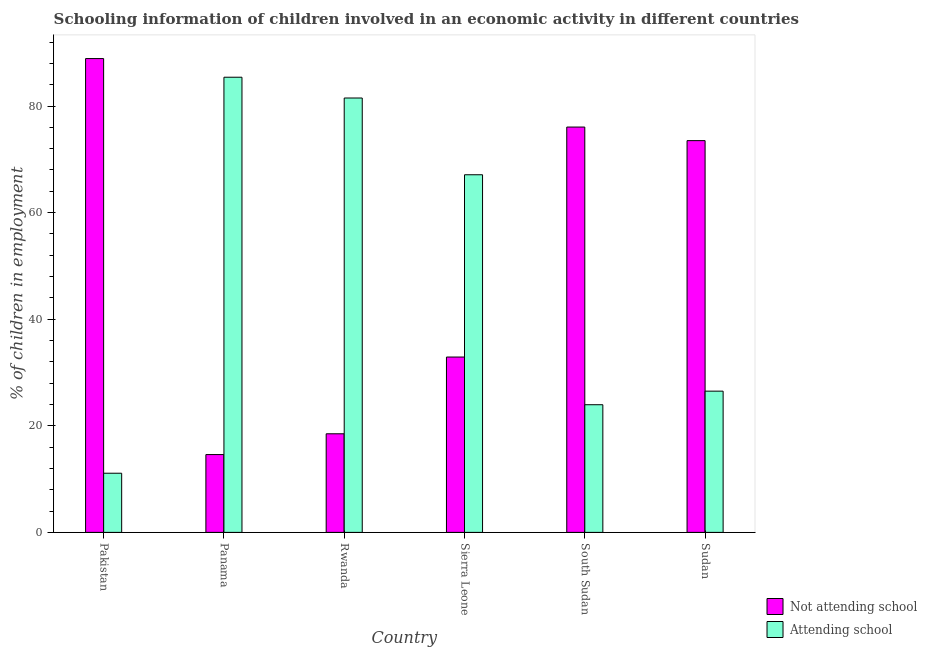Are the number of bars on each tick of the X-axis equal?
Give a very brief answer. Yes. How many bars are there on the 6th tick from the left?
Give a very brief answer. 2. How many bars are there on the 6th tick from the right?
Your response must be concise. 2. What is the label of the 5th group of bars from the left?
Provide a short and direct response. South Sudan. What is the percentage of employed children who are not attending school in South Sudan?
Ensure brevity in your answer.  76.05. Across all countries, what is the maximum percentage of employed children who are attending school?
Provide a short and direct response. 85.4. Across all countries, what is the minimum percentage of employed children who are not attending school?
Your response must be concise. 14.6. What is the total percentage of employed children who are not attending school in the graph?
Offer a terse response. 304.45. What is the difference between the percentage of employed children who are attending school in South Sudan and that in Sudan?
Provide a short and direct response. -2.55. What is the difference between the percentage of employed children who are not attending school in Sierra Leone and the percentage of employed children who are attending school in South Sudan?
Ensure brevity in your answer.  8.95. What is the average percentage of employed children who are not attending school per country?
Ensure brevity in your answer.  50.74. What is the difference between the percentage of employed children who are attending school and percentage of employed children who are not attending school in Pakistan?
Your response must be concise. -77.8. What is the ratio of the percentage of employed children who are not attending school in South Sudan to that in Sudan?
Your answer should be very brief. 1.03. Is the difference between the percentage of employed children who are attending school in Rwanda and Sudan greater than the difference between the percentage of employed children who are not attending school in Rwanda and Sudan?
Make the answer very short. Yes. What is the difference between the highest and the second highest percentage of employed children who are attending school?
Make the answer very short. 3.9. What is the difference between the highest and the lowest percentage of employed children who are not attending school?
Your answer should be compact. 74.3. In how many countries, is the percentage of employed children who are not attending school greater than the average percentage of employed children who are not attending school taken over all countries?
Keep it short and to the point. 3. Is the sum of the percentage of employed children who are not attending school in Pakistan and Panama greater than the maximum percentage of employed children who are attending school across all countries?
Your response must be concise. Yes. What does the 2nd bar from the left in Rwanda represents?
Your answer should be compact. Attending school. What does the 1st bar from the right in Sudan represents?
Your response must be concise. Attending school. How many bars are there?
Offer a terse response. 12. What is the difference between two consecutive major ticks on the Y-axis?
Provide a succinct answer. 20. Are the values on the major ticks of Y-axis written in scientific E-notation?
Your answer should be very brief. No. How many legend labels are there?
Provide a short and direct response. 2. How are the legend labels stacked?
Keep it short and to the point. Vertical. What is the title of the graph?
Your response must be concise. Schooling information of children involved in an economic activity in different countries. What is the label or title of the Y-axis?
Keep it short and to the point. % of children in employment. What is the % of children in employment in Not attending school in Pakistan?
Provide a succinct answer. 88.9. What is the % of children in employment in Attending school in Pakistan?
Your answer should be very brief. 11.1. What is the % of children in employment in Not attending school in Panama?
Offer a very short reply. 14.6. What is the % of children in employment in Attending school in Panama?
Ensure brevity in your answer.  85.4. What is the % of children in employment of Not attending school in Rwanda?
Provide a succinct answer. 18.5. What is the % of children in employment in Attending school in Rwanda?
Provide a short and direct response. 81.5. What is the % of children in employment of Not attending school in Sierra Leone?
Your answer should be compact. 32.9. What is the % of children in employment of Attending school in Sierra Leone?
Offer a terse response. 67.1. What is the % of children in employment in Not attending school in South Sudan?
Your response must be concise. 76.05. What is the % of children in employment in Attending school in South Sudan?
Ensure brevity in your answer.  23.95. What is the % of children in employment in Not attending school in Sudan?
Your response must be concise. 73.5. What is the % of children in employment of Attending school in Sudan?
Make the answer very short. 26.5. Across all countries, what is the maximum % of children in employment in Not attending school?
Provide a short and direct response. 88.9. Across all countries, what is the maximum % of children in employment in Attending school?
Your answer should be very brief. 85.4. What is the total % of children in employment of Not attending school in the graph?
Give a very brief answer. 304.45. What is the total % of children in employment of Attending school in the graph?
Give a very brief answer. 295.55. What is the difference between the % of children in employment in Not attending school in Pakistan and that in Panama?
Your answer should be compact. 74.3. What is the difference between the % of children in employment of Attending school in Pakistan and that in Panama?
Offer a terse response. -74.3. What is the difference between the % of children in employment in Not attending school in Pakistan and that in Rwanda?
Provide a short and direct response. 70.4. What is the difference between the % of children in employment of Attending school in Pakistan and that in Rwanda?
Offer a very short reply. -70.4. What is the difference between the % of children in employment in Attending school in Pakistan and that in Sierra Leone?
Provide a short and direct response. -56. What is the difference between the % of children in employment of Not attending school in Pakistan and that in South Sudan?
Your answer should be compact. 12.85. What is the difference between the % of children in employment in Attending school in Pakistan and that in South Sudan?
Your response must be concise. -12.85. What is the difference between the % of children in employment of Not attending school in Pakistan and that in Sudan?
Make the answer very short. 15.4. What is the difference between the % of children in employment in Attending school in Pakistan and that in Sudan?
Your answer should be compact. -15.4. What is the difference between the % of children in employment of Not attending school in Panama and that in Rwanda?
Keep it short and to the point. -3.9. What is the difference between the % of children in employment of Not attending school in Panama and that in Sierra Leone?
Offer a terse response. -18.3. What is the difference between the % of children in employment in Not attending school in Panama and that in South Sudan?
Provide a short and direct response. -61.45. What is the difference between the % of children in employment of Attending school in Panama and that in South Sudan?
Give a very brief answer. 61.45. What is the difference between the % of children in employment in Not attending school in Panama and that in Sudan?
Your answer should be very brief. -58.9. What is the difference between the % of children in employment of Attending school in Panama and that in Sudan?
Give a very brief answer. 58.9. What is the difference between the % of children in employment of Not attending school in Rwanda and that in Sierra Leone?
Offer a very short reply. -14.4. What is the difference between the % of children in employment of Attending school in Rwanda and that in Sierra Leone?
Offer a very short reply. 14.4. What is the difference between the % of children in employment of Not attending school in Rwanda and that in South Sudan?
Offer a very short reply. -57.55. What is the difference between the % of children in employment of Attending school in Rwanda and that in South Sudan?
Your answer should be very brief. 57.55. What is the difference between the % of children in employment in Not attending school in Rwanda and that in Sudan?
Your response must be concise. -55. What is the difference between the % of children in employment of Attending school in Rwanda and that in Sudan?
Give a very brief answer. 55. What is the difference between the % of children in employment in Not attending school in Sierra Leone and that in South Sudan?
Your answer should be very brief. -43.15. What is the difference between the % of children in employment of Attending school in Sierra Leone and that in South Sudan?
Make the answer very short. 43.15. What is the difference between the % of children in employment in Not attending school in Sierra Leone and that in Sudan?
Offer a terse response. -40.6. What is the difference between the % of children in employment in Attending school in Sierra Leone and that in Sudan?
Your response must be concise. 40.6. What is the difference between the % of children in employment of Not attending school in South Sudan and that in Sudan?
Your response must be concise. 2.55. What is the difference between the % of children in employment of Attending school in South Sudan and that in Sudan?
Give a very brief answer. -2.55. What is the difference between the % of children in employment in Not attending school in Pakistan and the % of children in employment in Attending school in Rwanda?
Your answer should be compact. 7.4. What is the difference between the % of children in employment in Not attending school in Pakistan and the % of children in employment in Attending school in Sierra Leone?
Provide a succinct answer. 21.8. What is the difference between the % of children in employment in Not attending school in Pakistan and the % of children in employment in Attending school in South Sudan?
Offer a terse response. 64.95. What is the difference between the % of children in employment in Not attending school in Pakistan and the % of children in employment in Attending school in Sudan?
Offer a very short reply. 62.4. What is the difference between the % of children in employment in Not attending school in Panama and the % of children in employment in Attending school in Rwanda?
Give a very brief answer. -66.9. What is the difference between the % of children in employment in Not attending school in Panama and the % of children in employment in Attending school in Sierra Leone?
Make the answer very short. -52.5. What is the difference between the % of children in employment in Not attending school in Panama and the % of children in employment in Attending school in South Sudan?
Give a very brief answer. -9.35. What is the difference between the % of children in employment of Not attending school in Panama and the % of children in employment of Attending school in Sudan?
Keep it short and to the point. -11.9. What is the difference between the % of children in employment of Not attending school in Rwanda and the % of children in employment of Attending school in Sierra Leone?
Your answer should be very brief. -48.6. What is the difference between the % of children in employment of Not attending school in Rwanda and the % of children in employment of Attending school in South Sudan?
Provide a short and direct response. -5.45. What is the difference between the % of children in employment in Not attending school in Rwanda and the % of children in employment in Attending school in Sudan?
Your answer should be compact. -8. What is the difference between the % of children in employment of Not attending school in Sierra Leone and the % of children in employment of Attending school in South Sudan?
Offer a very short reply. 8.95. What is the difference between the % of children in employment of Not attending school in Sierra Leone and the % of children in employment of Attending school in Sudan?
Keep it short and to the point. 6.4. What is the difference between the % of children in employment of Not attending school in South Sudan and the % of children in employment of Attending school in Sudan?
Offer a terse response. 49.55. What is the average % of children in employment in Not attending school per country?
Provide a succinct answer. 50.74. What is the average % of children in employment in Attending school per country?
Keep it short and to the point. 49.26. What is the difference between the % of children in employment in Not attending school and % of children in employment in Attending school in Pakistan?
Make the answer very short. 77.8. What is the difference between the % of children in employment in Not attending school and % of children in employment in Attending school in Panama?
Ensure brevity in your answer.  -70.8. What is the difference between the % of children in employment of Not attending school and % of children in employment of Attending school in Rwanda?
Your answer should be very brief. -63. What is the difference between the % of children in employment in Not attending school and % of children in employment in Attending school in Sierra Leone?
Ensure brevity in your answer.  -34.2. What is the difference between the % of children in employment of Not attending school and % of children in employment of Attending school in South Sudan?
Provide a succinct answer. 52.1. What is the difference between the % of children in employment in Not attending school and % of children in employment in Attending school in Sudan?
Offer a terse response. 47. What is the ratio of the % of children in employment of Not attending school in Pakistan to that in Panama?
Your response must be concise. 6.09. What is the ratio of the % of children in employment of Attending school in Pakistan to that in Panama?
Provide a succinct answer. 0.13. What is the ratio of the % of children in employment of Not attending school in Pakistan to that in Rwanda?
Offer a terse response. 4.81. What is the ratio of the % of children in employment of Attending school in Pakistan to that in Rwanda?
Your answer should be very brief. 0.14. What is the ratio of the % of children in employment in Not attending school in Pakistan to that in Sierra Leone?
Give a very brief answer. 2.7. What is the ratio of the % of children in employment in Attending school in Pakistan to that in Sierra Leone?
Give a very brief answer. 0.17. What is the ratio of the % of children in employment in Not attending school in Pakistan to that in South Sudan?
Give a very brief answer. 1.17. What is the ratio of the % of children in employment in Attending school in Pakistan to that in South Sudan?
Make the answer very short. 0.46. What is the ratio of the % of children in employment in Not attending school in Pakistan to that in Sudan?
Offer a terse response. 1.21. What is the ratio of the % of children in employment in Attending school in Pakistan to that in Sudan?
Ensure brevity in your answer.  0.42. What is the ratio of the % of children in employment of Not attending school in Panama to that in Rwanda?
Provide a short and direct response. 0.79. What is the ratio of the % of children in employment of Attending school in Panama to that in Rwanda?
Give a very brief answer. 1.05. What is the ratio of the % of children in employment in Not attending school in Panama to that in Sierra Leone?
Ensure brevity in your answer.  0.44. What is the ratio of the % of children in employment of Attending school in Panama to that in Sierra Leone?
Provide a short and direct response. 1.27. What is the ratio of the % of children in employment in Not attending school in Panama to that in South Sudan?
Offer a very short reply. 0.19. What is the ratio of the % of children in employment in Attending school in Panama to that in South Sudan?
Offer a very short reply. 3.57. What is the ratio of the % of children in employment of Not attending school in Panama to that in Sudan?
Offer a very short reply. 0.2. What is the ratio of the % of children in employment of Attending school in Panama to that in Sudan?
Provide a short and direct response. 3.22. What is the ratio of the % of children in employment of Not attending school in Rwanda to that in Sierra Leone?
Your answer should be compact. 0.56. What is the ratio of the % of children in employment of Attending school in Rwanda to that in Sierra Leone?
Ensure brevity in your answer.  1.21. What is the ratio of the % of children in employment in Not attending school in Rwanda to that in South Sudan?
Give a very brief answer. 0.24. What is the ratio of the % of children in employment in Attending school in Rwanda to that in South Sudan?
Make the answer very short. 3.4. What is the ratio of the % of children in employment in Not attending school in Rwanda to that in Sudan?
Provide a short and direct response. 0.25. What is the ratio of the % of children in employment in Attending school in Rwanda to that in Sudan?
Ensure brevity in your answer.  3.08. What is the ratio of the % of children in employment of Not attending school in Sierra Leone to that in South Sudan?
Offer a very short reply. 0.43. What is the ratio of the % of children in employment in Attending school in Sierra Leone to that in South Sudan?
Give a very brief answer. 2.8. What is the ratio of the % of children in employment in Not attending school in Sierra Leone to that in Sudan?
Offer a terse response. 0.45. What is the ratio of the % of children in employment of Attending school in Sierra Leone to that in Sudan?
Give a very brief answer. 2.53. What is the ratio of the % of children in employment of Not attending school in South Sudan to that in Sudan?
Provide a short and direct response. 1.03. What is the ratio of the % of children in employment in Attending school in South Sudan to that in Sudan?
Ensure brevity in your answer.  0.9. What is the difference between the highest and the second highest % of children in employment in Not attending school?
Provide a short and direct response. 12.85. What is the difference between the highest and the second highest % of children in employment in Attending school?
Your answer should be very brief. 3.9. What is the difference between the highest and the lowest % of children in employment of Not attending school?
Provide a short and direct response. 74.3. What is the difference between the highest and the lowest % of children in employment in Attending school?
Offer a terse response. 74.3. 